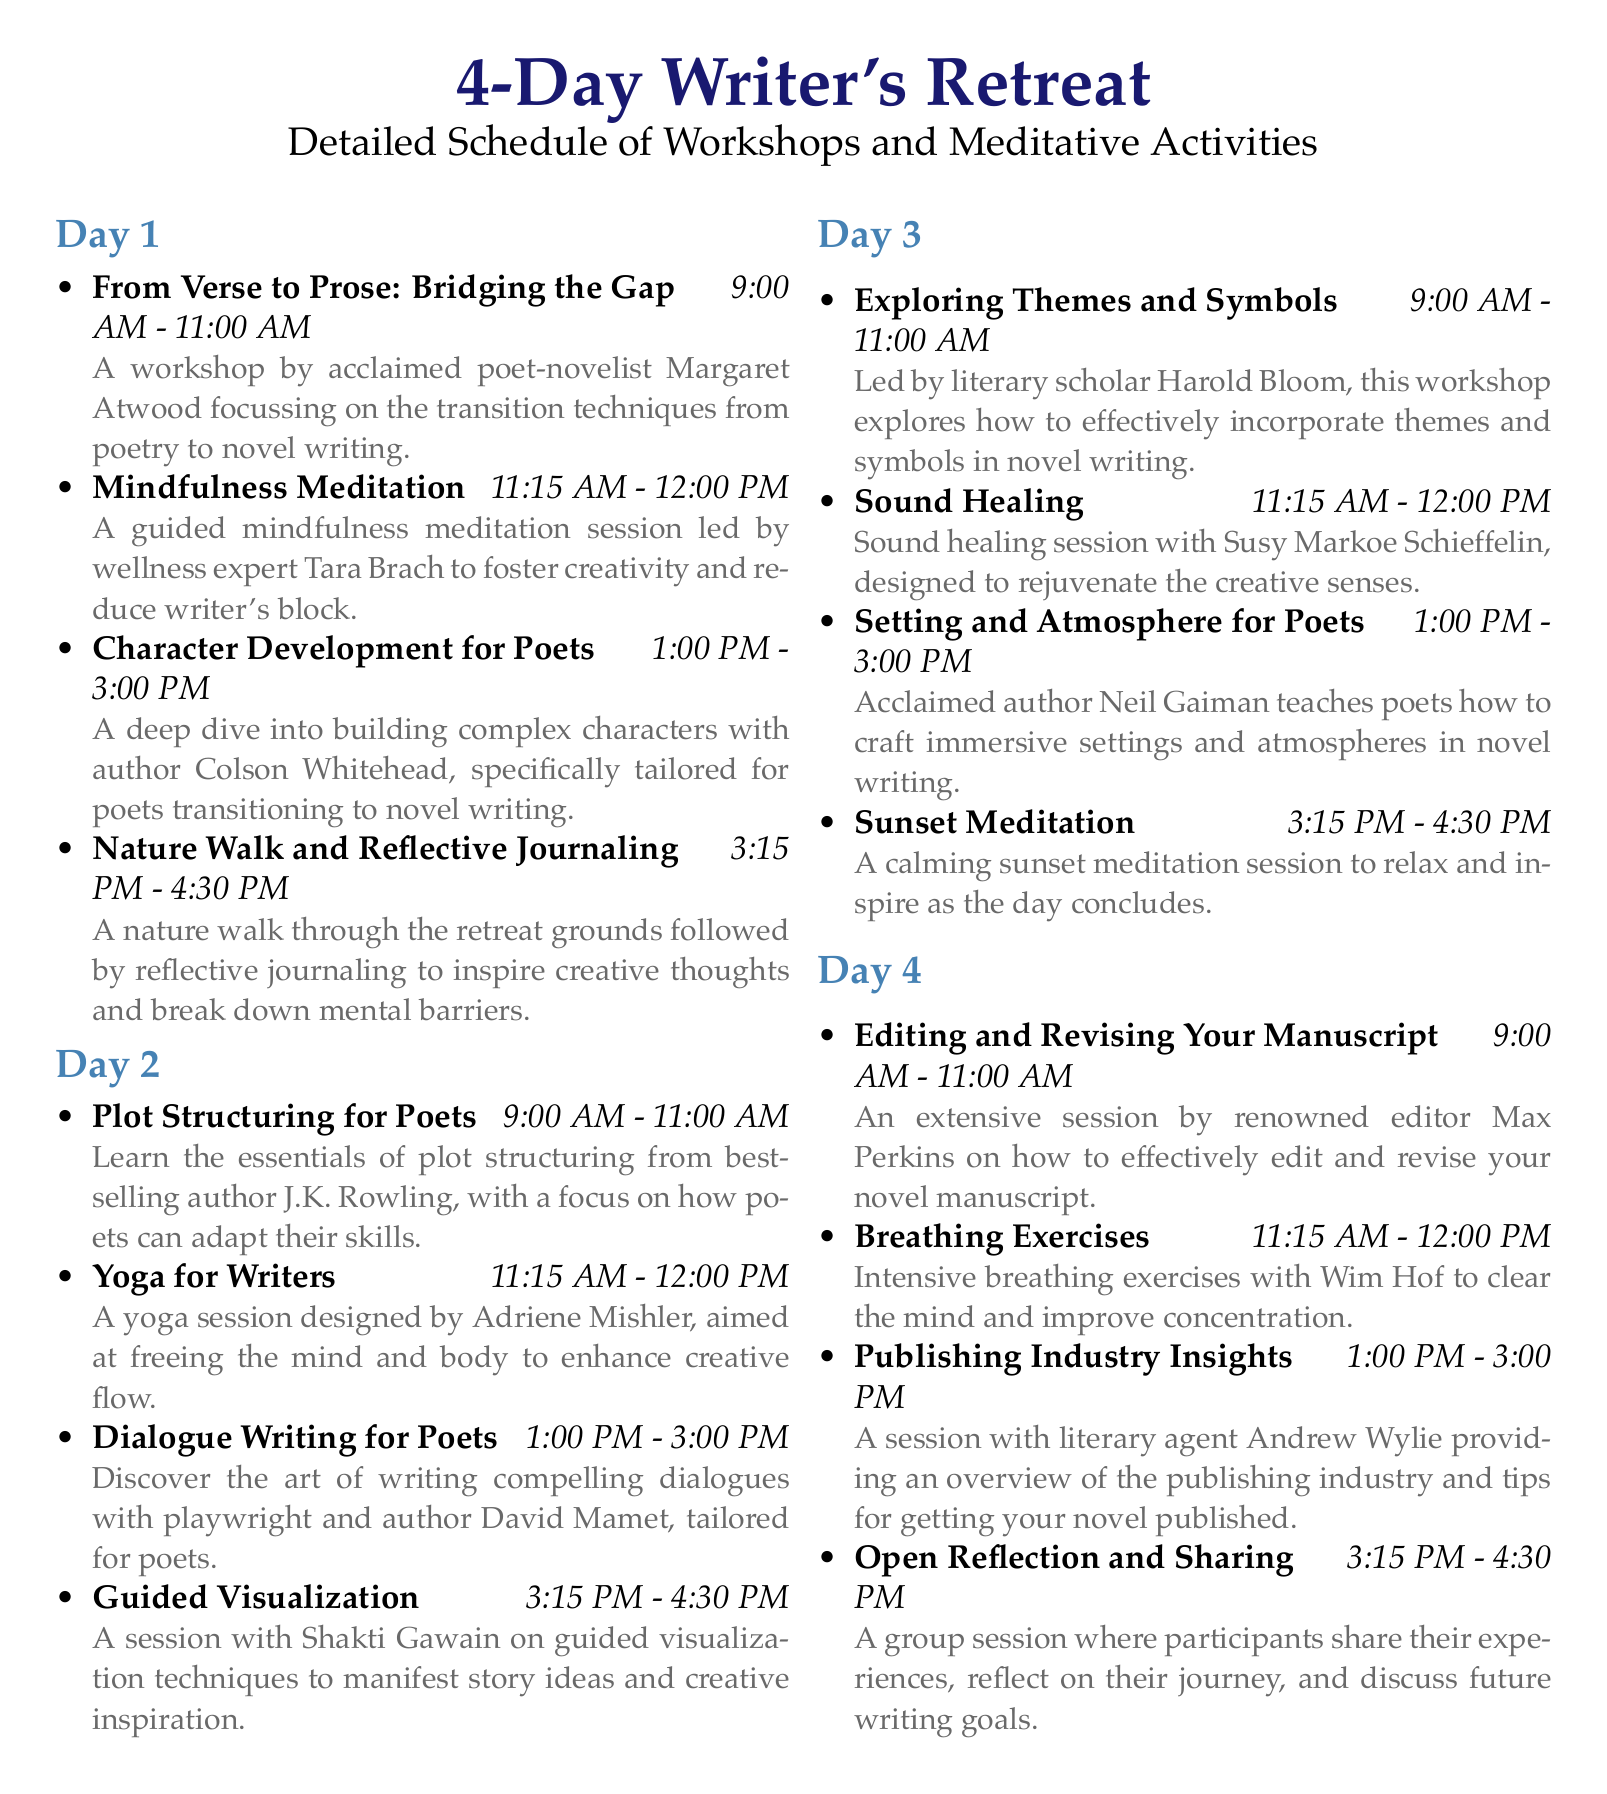What is the name of the poet-novelist leading the first workshop? The document specifies that Margaret Atwood is leading the workshop on bridging poetry to prose.
Answer: Margaret Atwood What time does the Yoga for Writers session begin? The schedule indicates that Yoga for Writers starts at 11:15 AM on Day 2.
Answer: 11:15 AM Who is teaching the workshop on Setting and Atmosphere for Poets? Neil Gaiman is the acclaimed author leading this specific workshop.
Answer: Neil Gaiman What activity follows the Plot Structuring workshop on Day 2? The document lists a Yoga session as the activity that follows the Plot Structuring workshop.
Answer: Yoga for Writers How long is the Editing and Revising Your Manuscript session? The itinerary states that this session lasts for 2 hours, from 9:00 AM to 11:00 AM.
Answer: 2 hours What type of activity is held on Day 3 at 3:15 PM? At this time, a sunset meditation session is scheduled, focusing on relaxation and inspiration.
Answer: Sunset Meditation Who provides insights into the publishing industry on Day 4? Andrew Wylie is the literary agent who provides this information according to the schedule.
Answer: Andrew Wylie What is the theme of the guided mindfulness meditation session? The meditation session is aimed at fostering creativity and reducing writer's block.
Answer: Fostering creativity and reducing writer's block 